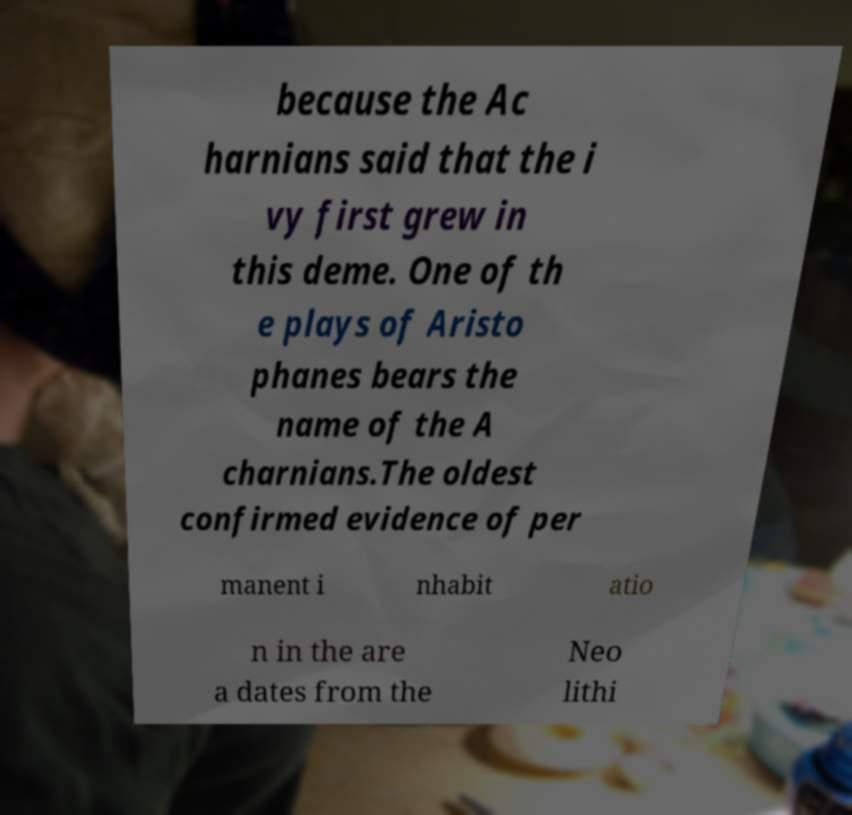Could you assist in decoding the text presented in this image and type it out clearly? because the Ac harnians said that the i vy first grew in this deme. One of th e plays of Aristo phanes bears the name of the A charnians.The oldest confirmed evidence of per manent i nhabit atio n in the are a dates from the Neo lithi 